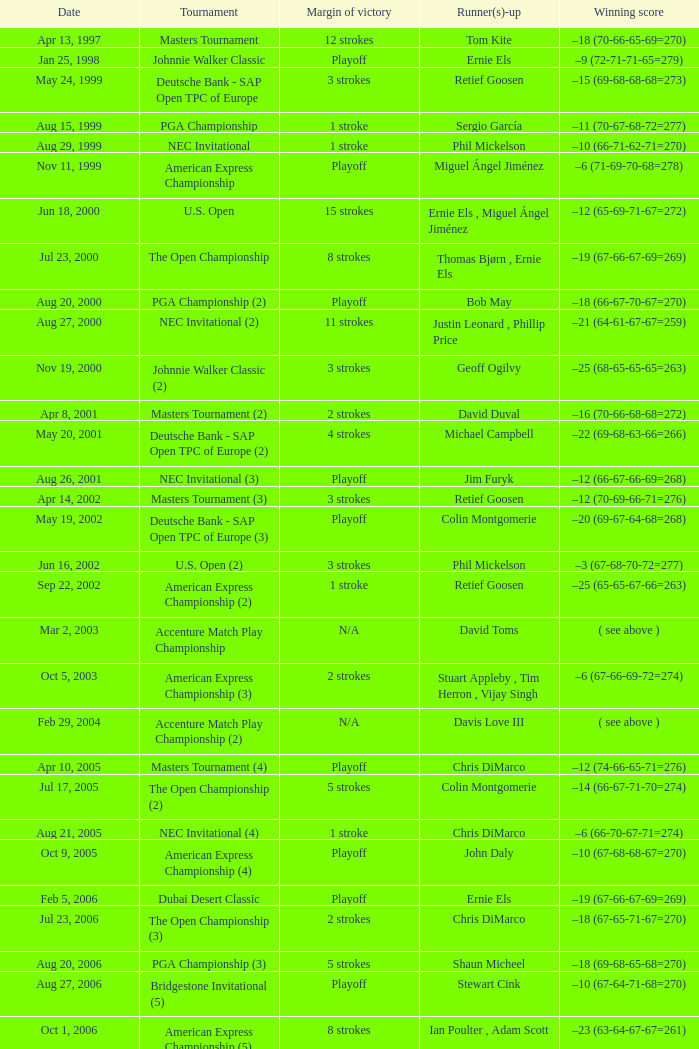Who has the Winning score of –10 (66-71-62-71=270) ? Phil Mickelson. 